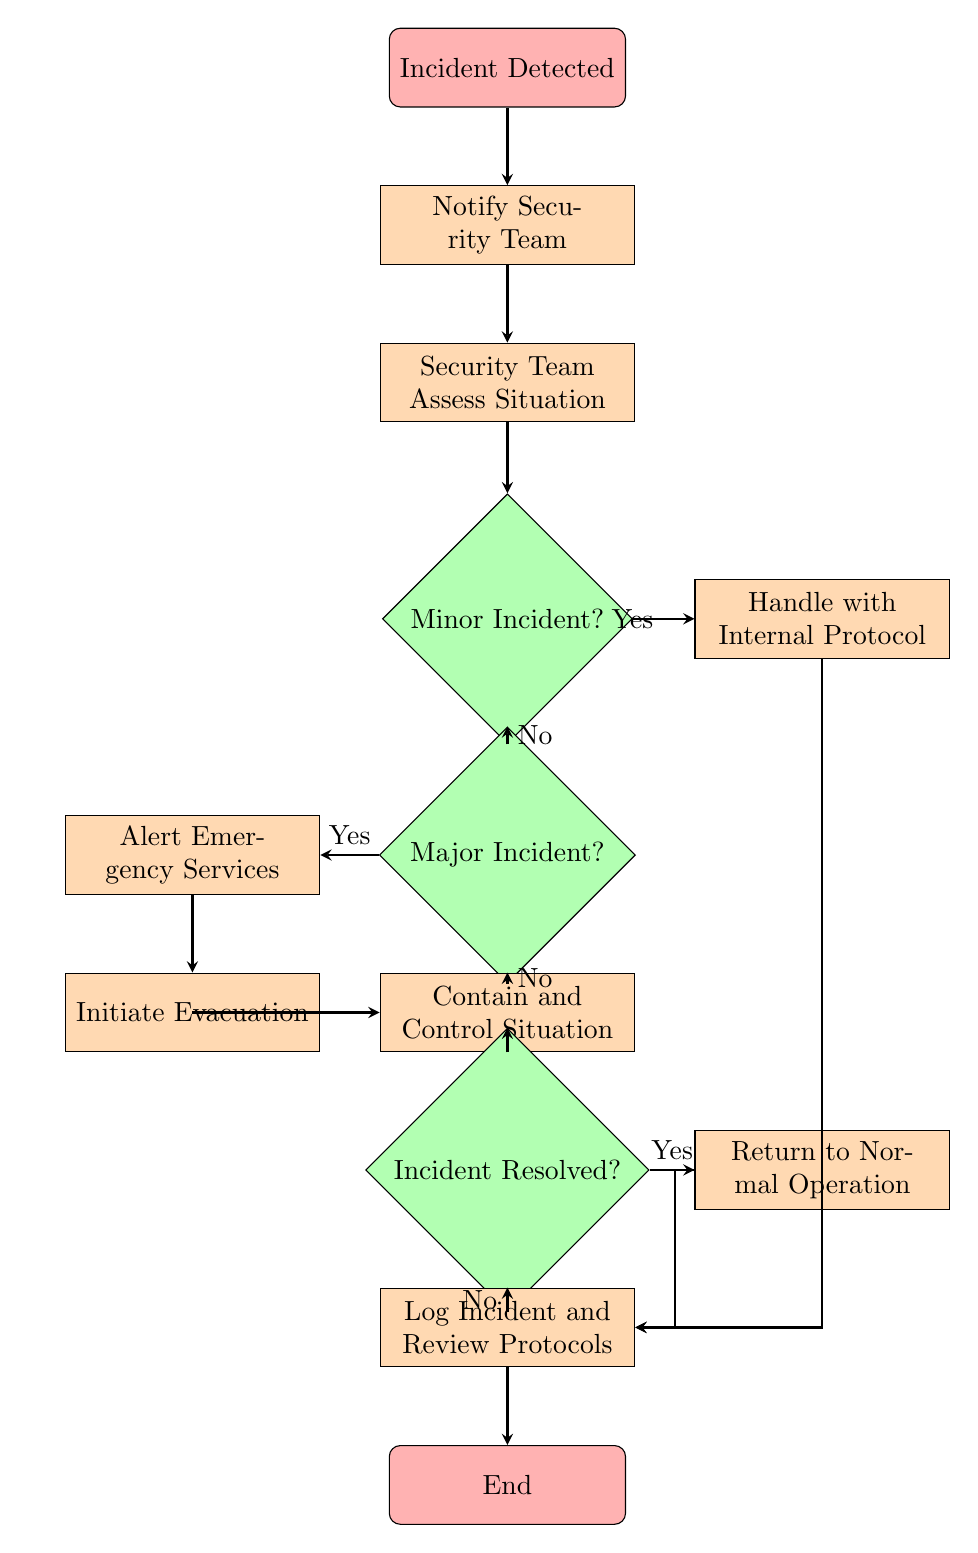what is the starting node of the flow chart? The flow chart begins with the node labeled "Incident Detected," which indicates the point at which an incident is first recognized.
Answer: Incident Detected how many decision nodes are present in the flow chart? There are three decision nodes, which are "Minor Incident?", "Major Incident?", and "Incident Resolved?". Each decision node leads to different paths in the incident response process.
Answer: 3 what is the process after the "Security Team Assess Situation" node? Following the "Security Team Assess Situation," the next step is to evaluate whether the incident is minor by checking the "Minor Incident?" decision node. This determines the subsequent steps based on the outcome.
Answer: Minor Incident? if the incident is classified as major, what is the first action to take? If the incident is classified as major, the first action to take is to "Alert Emergency Services," which is indicated by the arrow leading out of the "Major Incident?" decision node when the response is "Yes."
Answer: Alert Emergency Services what happens if the incident is resolved? If the incident is resolved, the next step is to "Return to Normal Operation," which follows the "Incident Resolved?" decision node when the outcome is "Yes." This indicates a return to standard procedures after handling the incident.
Answer: Return to Normal Operation what processes are involved in the flow chart after confirming a major incident? After confirming a major incident, the processes involved include "Alert Emergency Services," followed by "Initiate Evacuation," and continuing with "Contain and Control Situation" in order to manage the incident effectively.
Answer: Alert Emergency Services, Initiate Evacuation, Contain and Control Situation what should be done if a minor incident is confirmed? If a minor incident is confirmed, the action to take is to "Handle with Internal Protocol," which is executed immediately following the confirmation in the flow chart.
Answer: Handle with Internal Protocol how is the flow chart concluded? The flow chart is concluded by the node "End," which follows the completion of the processes logged after handling the incident, ensuring all actions have been documented and reviewed.
Answer: End 